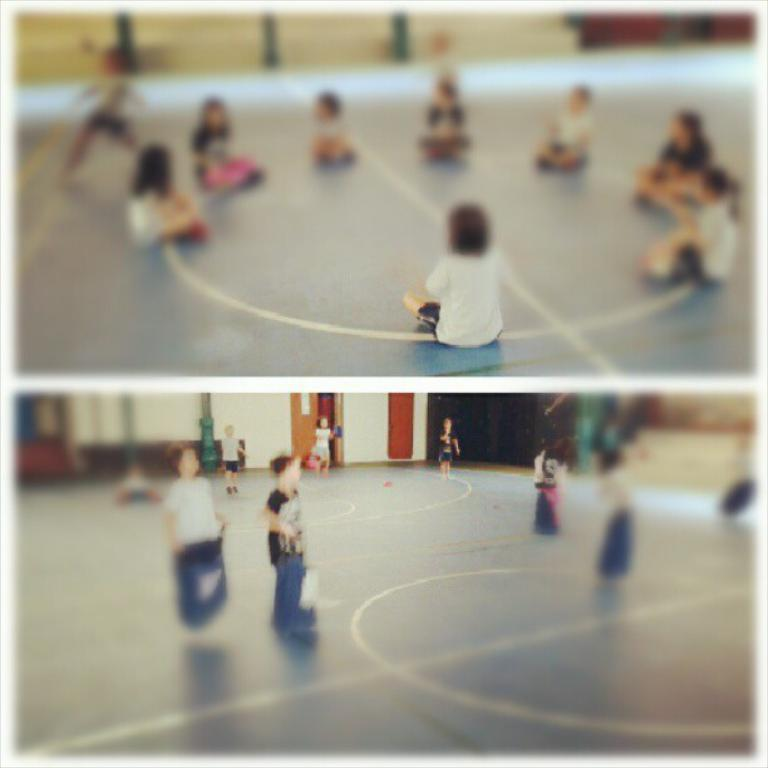How many people are in the image? There is a group of people in the image. What are the people doing in the image? The people are sitting on the ground. What can be seen in the background of the image? There is a wall and a door in the background of the image. What colors are the wall and door? The wall is in a cream color, and the door is in a brown color. Can you see a nest in the image? There is no nest present in the image. 